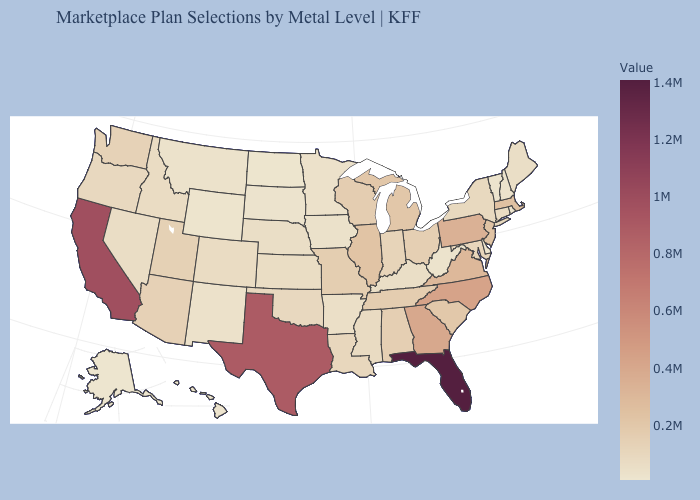Does Vermont have the lowest value in the Northeast?
Give a very brief answer. Yes. Does Maryland have the highest value in the USA?
Concise answer only. No. Among the states that border Texas , does New Mexico have the lowest value?
Short answer required. Yes. Among the states that border Missouri , which have the lowest value?
Write a very short answer. Iowa. Which states have the highest value in the USA?
Keep it brief. Florida. Which states have the highest value in the USA?
Quick response, please. Florida. 